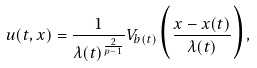<formula> <loc_0><loc_0><loc_500><loc_500>u ( t , x ) = \frac { 1 } { \lambda ( t ) ^ { \frac { 2 } { p - 1 } } } V _ { b ( t ) } \Big { ( } \frac { x - x ( t ) } { \lambda ( t ) } \Big { ) } ,</formula> 